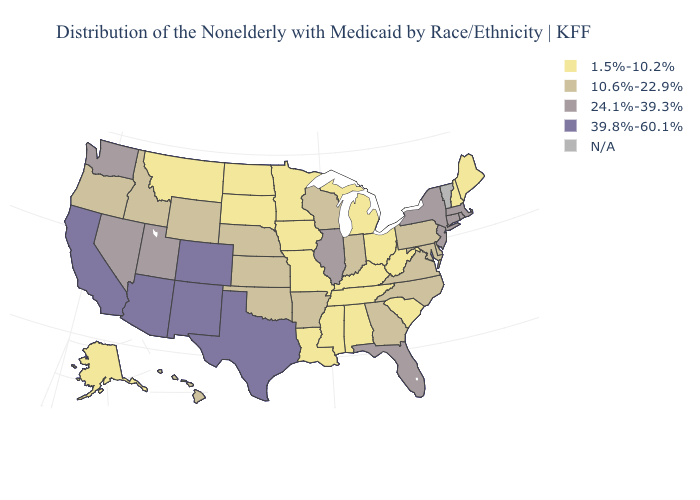Name the states that have a value in the range 1.5%-10.2%?
Short answer required. Alabama, Alaska, Iowa, Kentucky, Louisiana, Maine, Michigan, Minnesota, Mississippi, Missouri, Montana, New Hampshire, North Dakota, Ohio, South Carolina, South Dakota, Tennessee, West Virginia. Name the states that have a value in the range 39.8%-60.1%?
Keep it brief. Arizona, California, Colorado, New Mexico, Texas. What is the value of Hawaii?
Concise answer only. 10.6%-22.9%. What is the lowest value in states that border Mississippi?
Answer briefly. 1.5%-10.2%. Among the states that border New Jersey , does Delaware have the lowest value?
Give a very brief answer. Yes. Does Pennsylvania have the highest value in the Northeast?
Write a very short answer. No. What is the highest value in the Northeast ?
Keep it brief. 24.1%-39.3%. Name the states that have a value in the range 39.8%-60.1%?
Be succinct. Arizona, California, Colorado, New Mexico, Texas. Name the states that have a value in the range 39.8%-60.1%?
Concise answer only. Arizona, California, Colorado, New Mexico, Texas. What is the value of Arizona?
Concise answer only. 39.8%-60.1%. What is the value of West Virginia?
Answer briefly. 1.5%-10.2%. What is the value of Michigan?
Answer briefly. 1.5%-10.2%. What is the highest value in the USA?
Keep it brief. 39.8%-60.1%. 